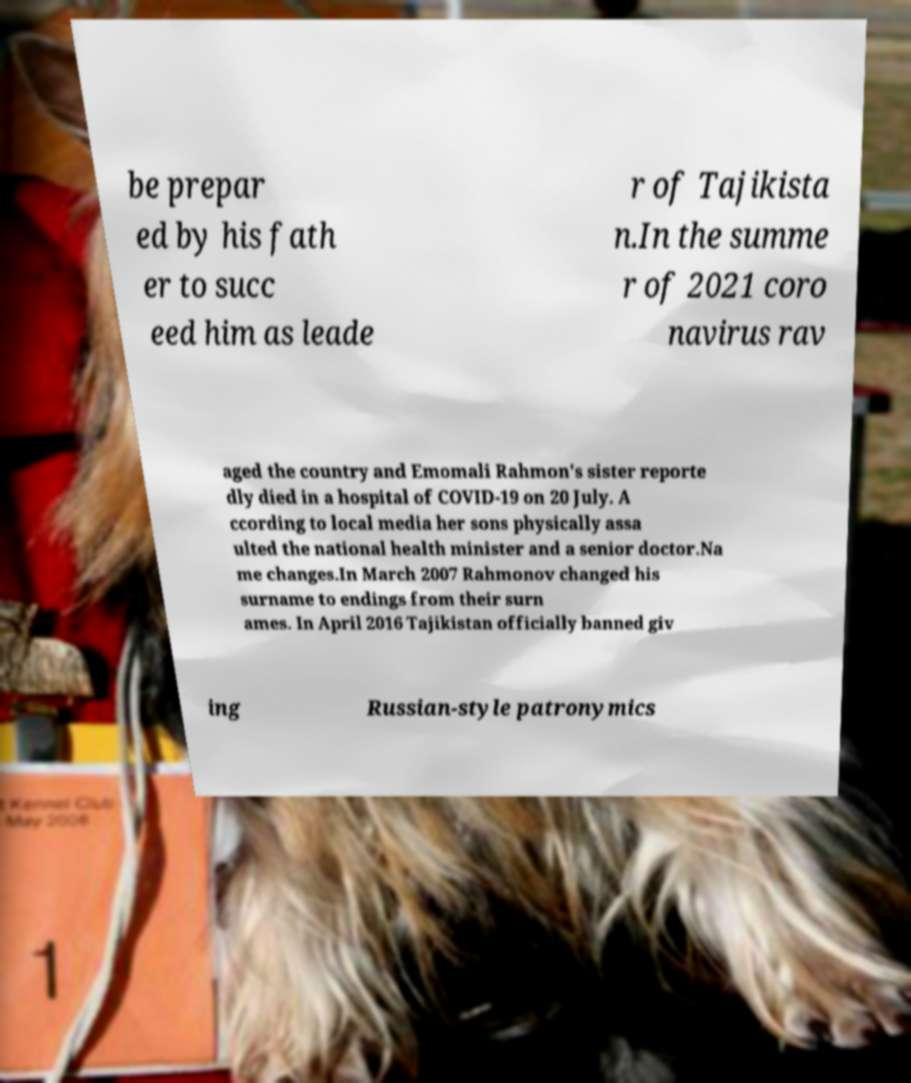For documentation purposes, I need the text within this image transcribed. Could you provide that? be prepar ed by his fath er to succ eed him as leade r of Tajikista n.In the summe r of 2021 coro navirus rav aged the country and Emomali Rahmon's sister reporte dly died in a hospital of COVID-19 on 20 July. A ccording to local media her sons physically assa ulted the national health minister and a senior doctor.Na me changes.In March 2007 Rahmonov changed his surname to endings from their surn ames. In April 2016 Tajikistan officially banned giv ing Russian-style patronymics 